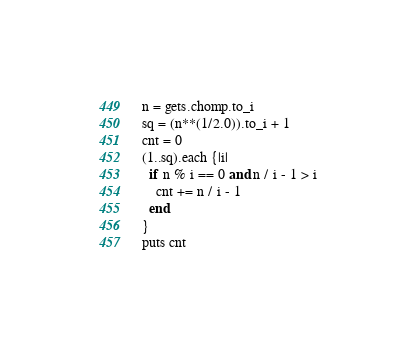<code> <loc_0><loc_0><loc_500><loc_500><_Ruby_>n = gets.chomp.to_i
sq = (n**(1/2.0)).to_i + 1
cnt = 0
(1..sq).each {|i|
  if n % i == 0 and n / i - 1 > i
    cnt += n / i - 1
  end
}
puts cnt
</code> 